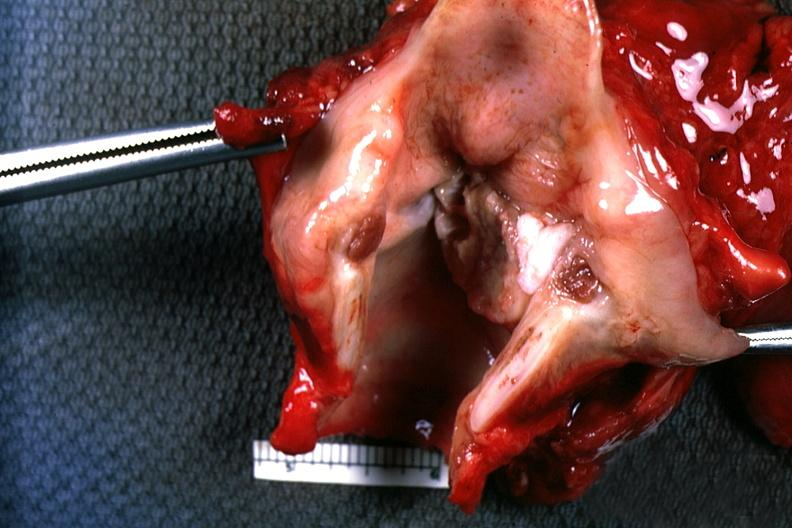what is present?
Answer the question using a single word or phrase. Larynx 